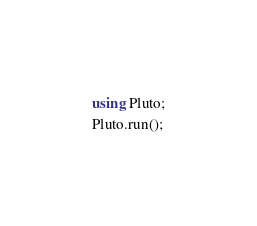Convert code to text. <code><loc_0><loc_0><loc_500><loc_500><_Julia_>using Pluto;
Pluto.run();</code> 